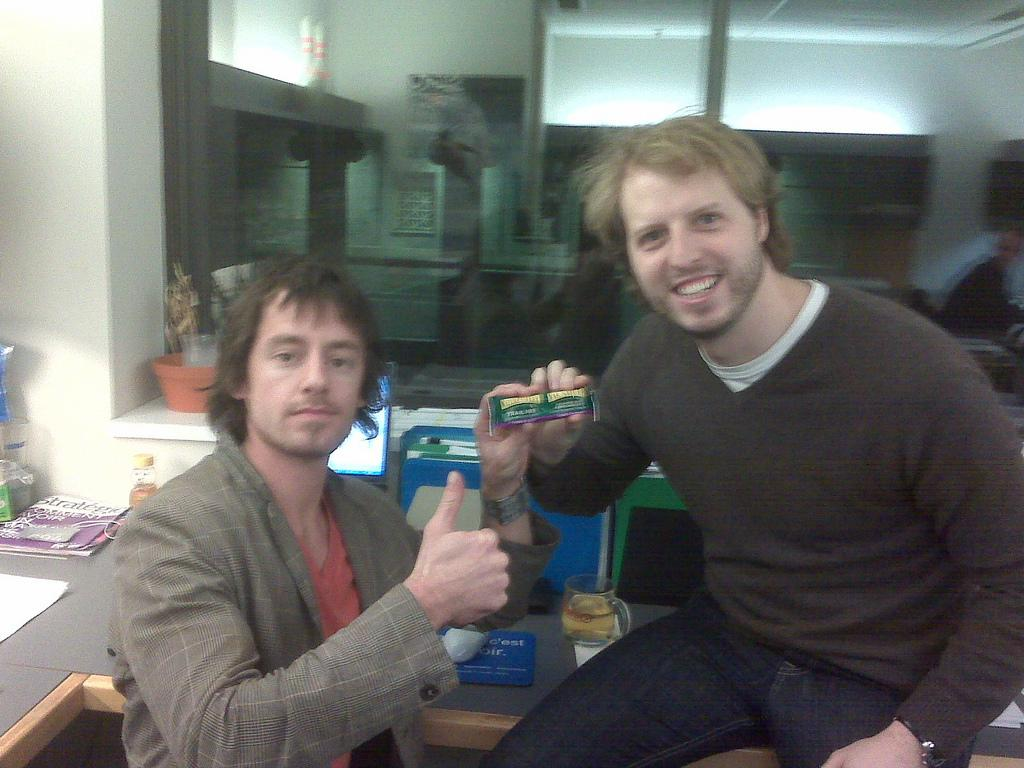How many people are in the image? There are two people in the image. What are the people doing in the image? The people are posing for the camera and smiling. What can be seen on a table in the image? There are objects on a table in the image. What type of architectural feature is visible in the image? There is a glass window visible in the image. What type of knife is being used to cut the zinc in the image? There is no knife or zinc present in the image. What type of meat is being prepared on the table in the image? There is no meat or preparation activity visible in the image. 